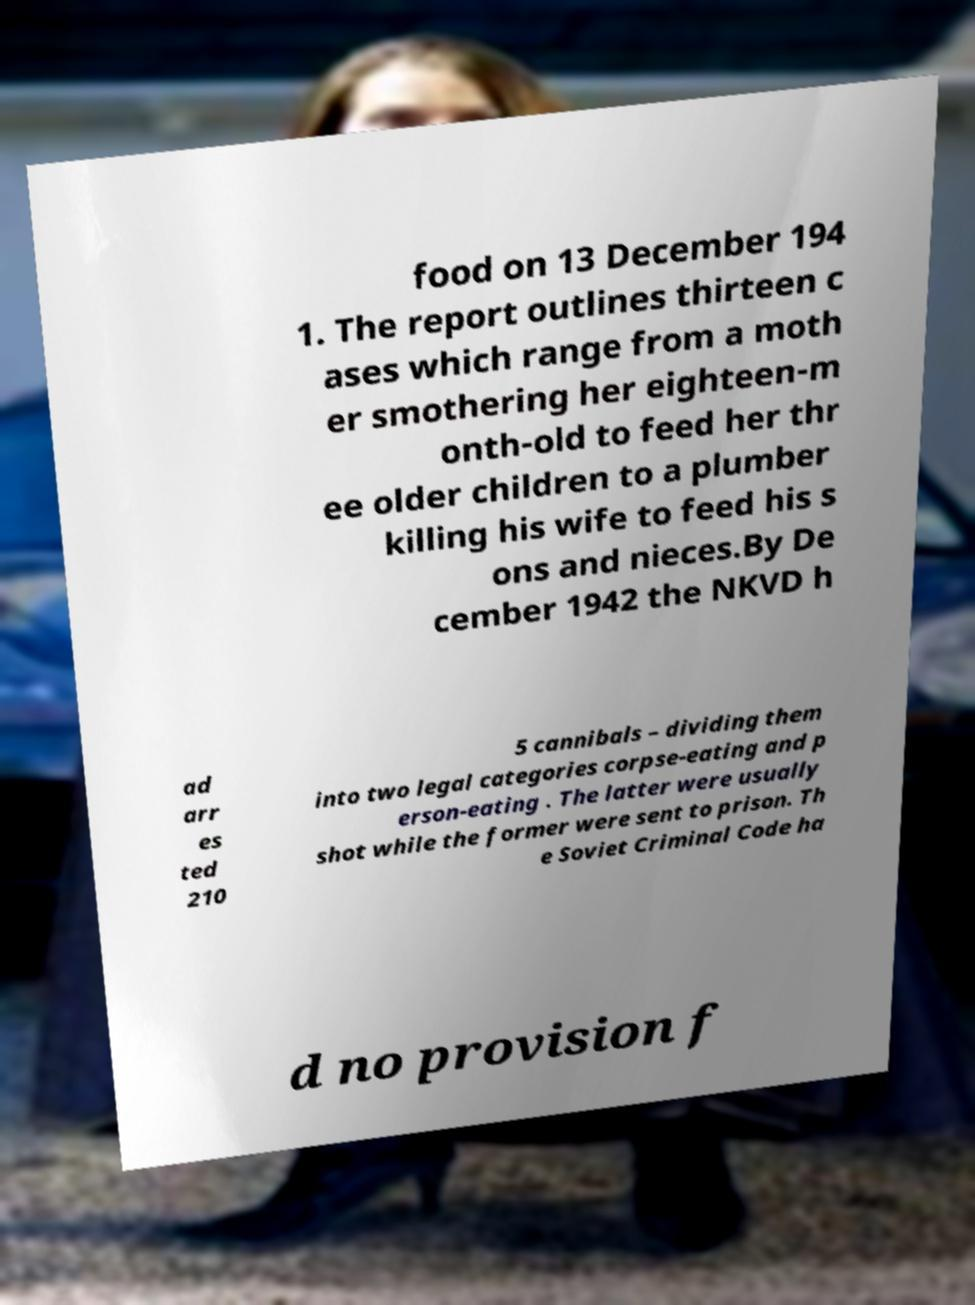Could you assist in decoding the text presented in this image and type it out clearly? food on 13 December 194 1. The report outlines thirteen c ases which range from a moth er smothering her eighteen-m onth-old to feed her thr ee older children to a plumber killing his wife to feed his s ons and nieces.By De cember 1942 the NKVD h ad arr es ted 210 5 cannibals – dividing them into two legal categories corpse-eating and p erson-eating . The latter were usually shot while the former were sent to prison. Th e Soviet Criminal Code ha d no provision f 